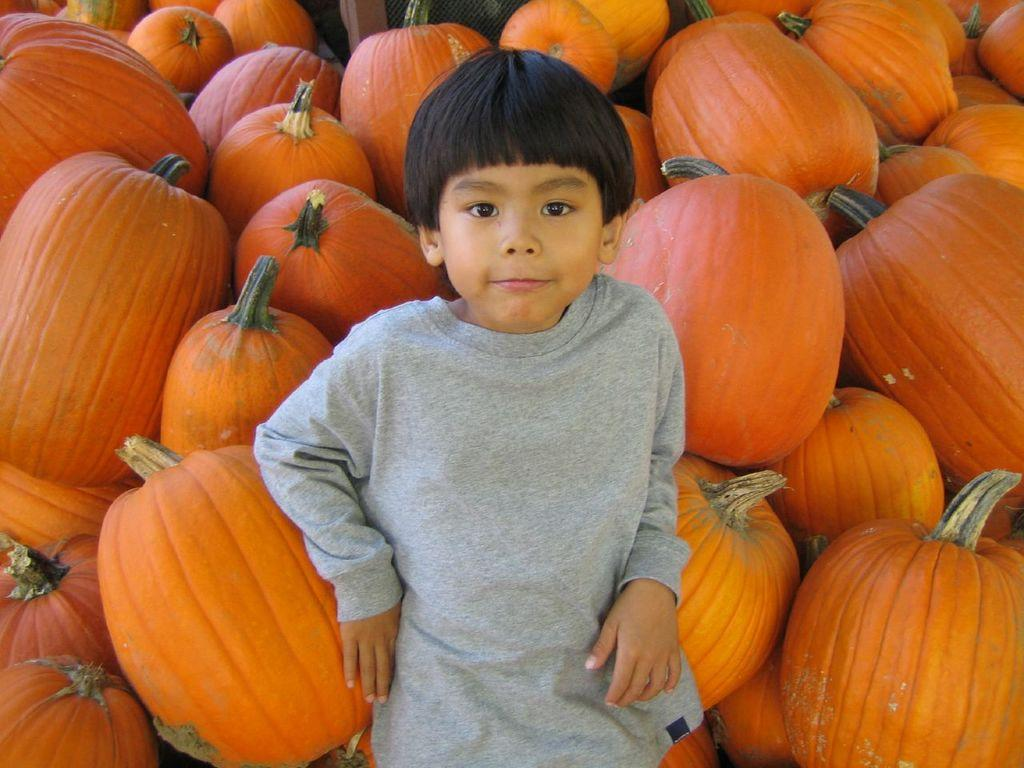What is the main subject of the image? The main subject of the image is many pumpkins. Are there any people present in the image? Yes, there is a boy in the image. What type of hat is the maid wearing in the image? There is no maid or hat present in the image. What is the lock used for in the image? There is no lock present in the image. 